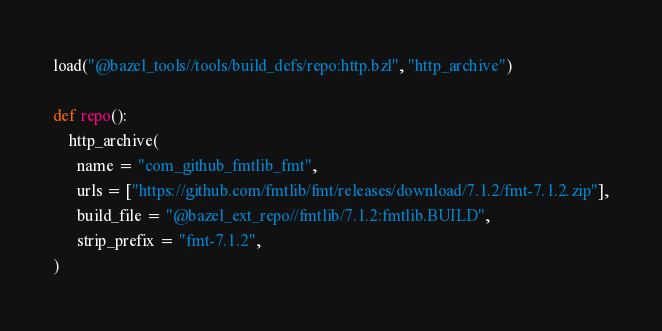Convert code to text. <code><loc_0><loc_0><loc_500><loc_500><_Python_>load("@bazel_tools//tools/build_defs/repo:http.bzl", "http_archive")

def repo():
    http_archive(
      name = "com_github_fmtlib_fmt",
      urls = ["https://github.com/fmtlib/fmt/releases/download/7.1.2/fmt-7.1.2.zip"],
      build_file = "@bazel_ext_repo//fmtlib/7.1.2:fmtlib.BUILD",
      strip_prefix = "fmt-7.1.2",
)</code> 